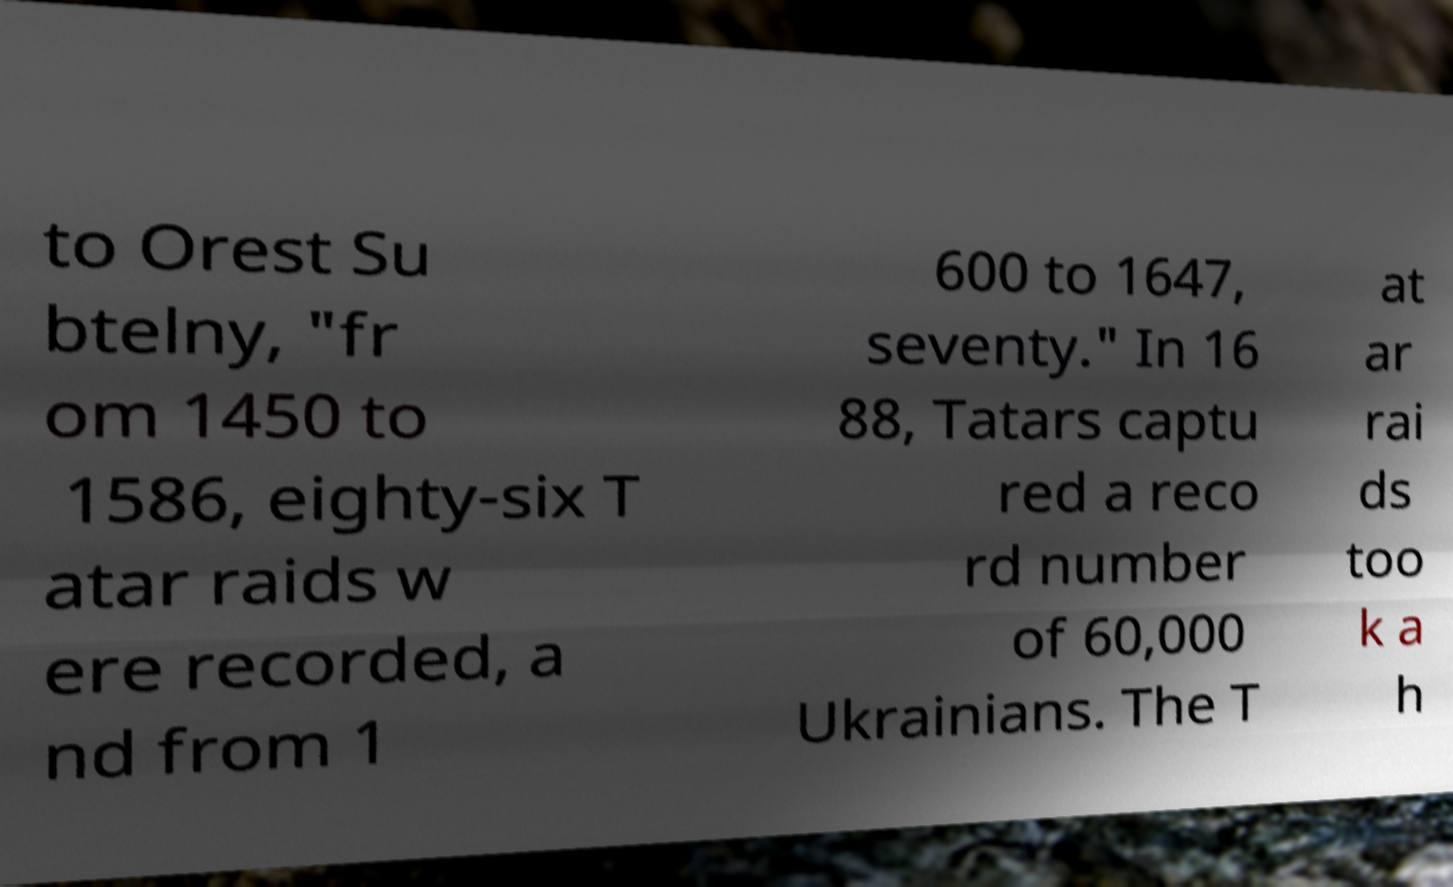Please identify and transcribe the text found in this image. to Orest Su btelny, "fr om 1450 to 1586, eighty-six T atar raids w ere recorded, a nd from 1 600 to 1647, seventy." In 16 88, Tatars captu red a reco rd number of 60,000 Ukrainians. The T at ar rai ds too k a h 